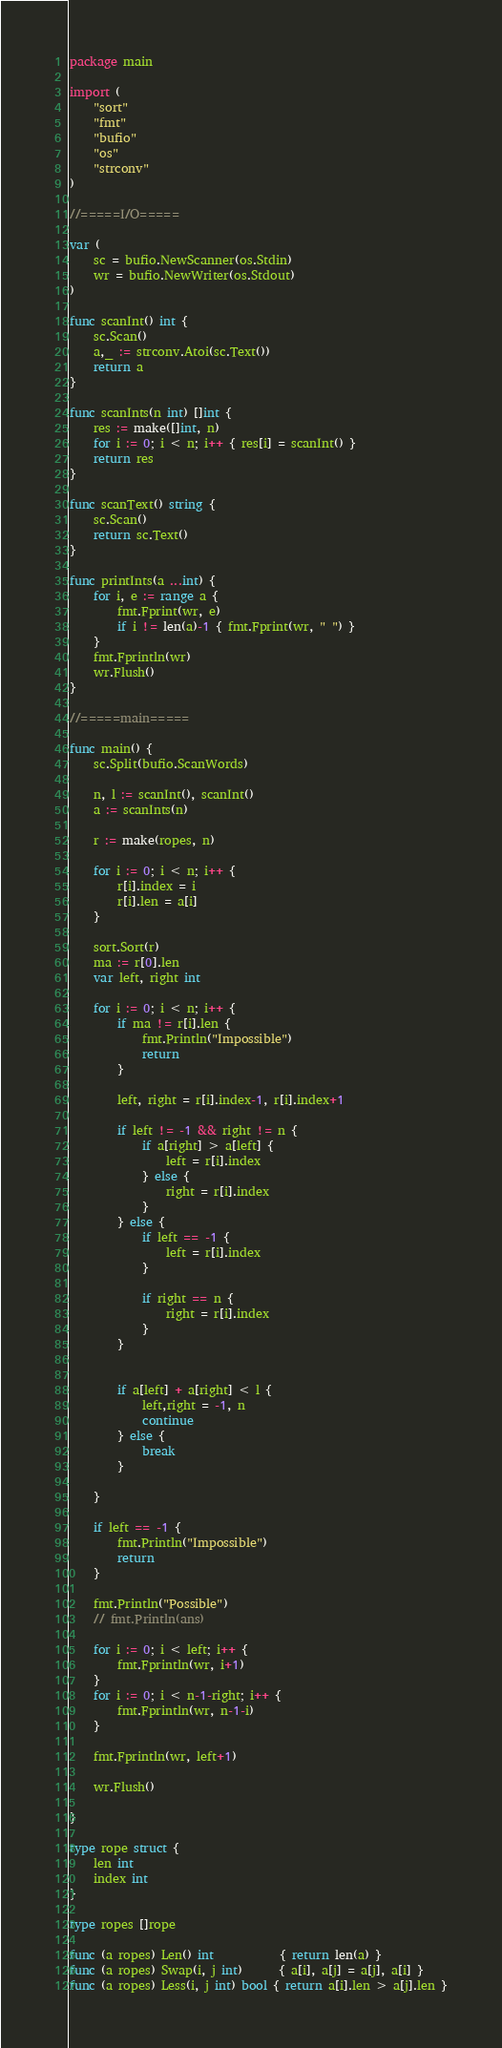<code> <loc_0><loc_0><loc_500><loc_500><_Go_>package main

import (
	"sort"
	"fmt"
	"bufio"
	"os"
	"strconv"
)

//=====I/O=====

var (
	sc = bufio.NewScanner(os.Stdin)
	wr = bufio.NewWriter(os.Stdout)
)

func scanInt() int {
	sc.Scan()
	a,_ := strconv.Atoi(sc.Text())
	return a
}

func scanInts(n int) []int {
	res := make([]int, n)
	for i := 0; i < n; i++ { res[i] = scanInt() }
	return res
}

func scanText() string {
	sc.Scan()
	return sc.Text()
}

func printInts(a ...int) {
	for i, e := range a {
		fmt.Fprint(wr, e)
		if i != len(a)-1 { fmt.Fprint(wr, " ") }
	}
	fmt.Fprintln(wr)
	wr.Flush()
}

//=====main=====

func main() {
	sc.Split(bufio.ScanWords)

	n, l := scanInt(), scanInt()
	a := scanInts(n)

	r := make(ropes, n)

	for i := 0; i < n; i++ {
		r[i].index = i
		r[i].len = a[i]
	}

	sort.Sort(r)
	ma := r[0].len
	var left, right int

	for i := 0; i < n; i++ {
		if ma != r[i].len {
			fmt.Println("Impossible")
			return
		}

		left, right = r[i].index-1, r[i].index+1

		if left != -1 && right != n {
			if a[right] > a[left] {
				left = r[i].index
			} else {
				right = r[i].index
			}
		} else {
			if left == -1 {
				left = r[i].index
			} 
	
			if right == n {
				right = r[i].index
			}
		}


		if a[left] + a[right] < l {
			left,right = -1, n
			continue
		} else {
			break
		}

	}

	if left == -1 {
		fmt.Println("Impossible")
		return
	}

	fmt.Println("Possible")
	// fmt.Println(ans)

	for i := 0; i < left; i++ {
		fmt.Fprintln(wr, i+1)
	}
	for i := 0; i < n-1-right; i++ {
		fmt.Fprintln(wr, n-1-i)
	}

	fmt.Fprintln(wr, left+1)

	wr.Flush()

}

type rope struct {
	len int
	index int
}

type ropes []rope

func (a ropes) Len() int           { return len(a) }
func (a ropes) Swap(i, j int)      { a[i], a[j] = a[j], a[i] }
func (a ropes) Less(i, j int) bool { return a[i].len > a[j].len }
</code> 